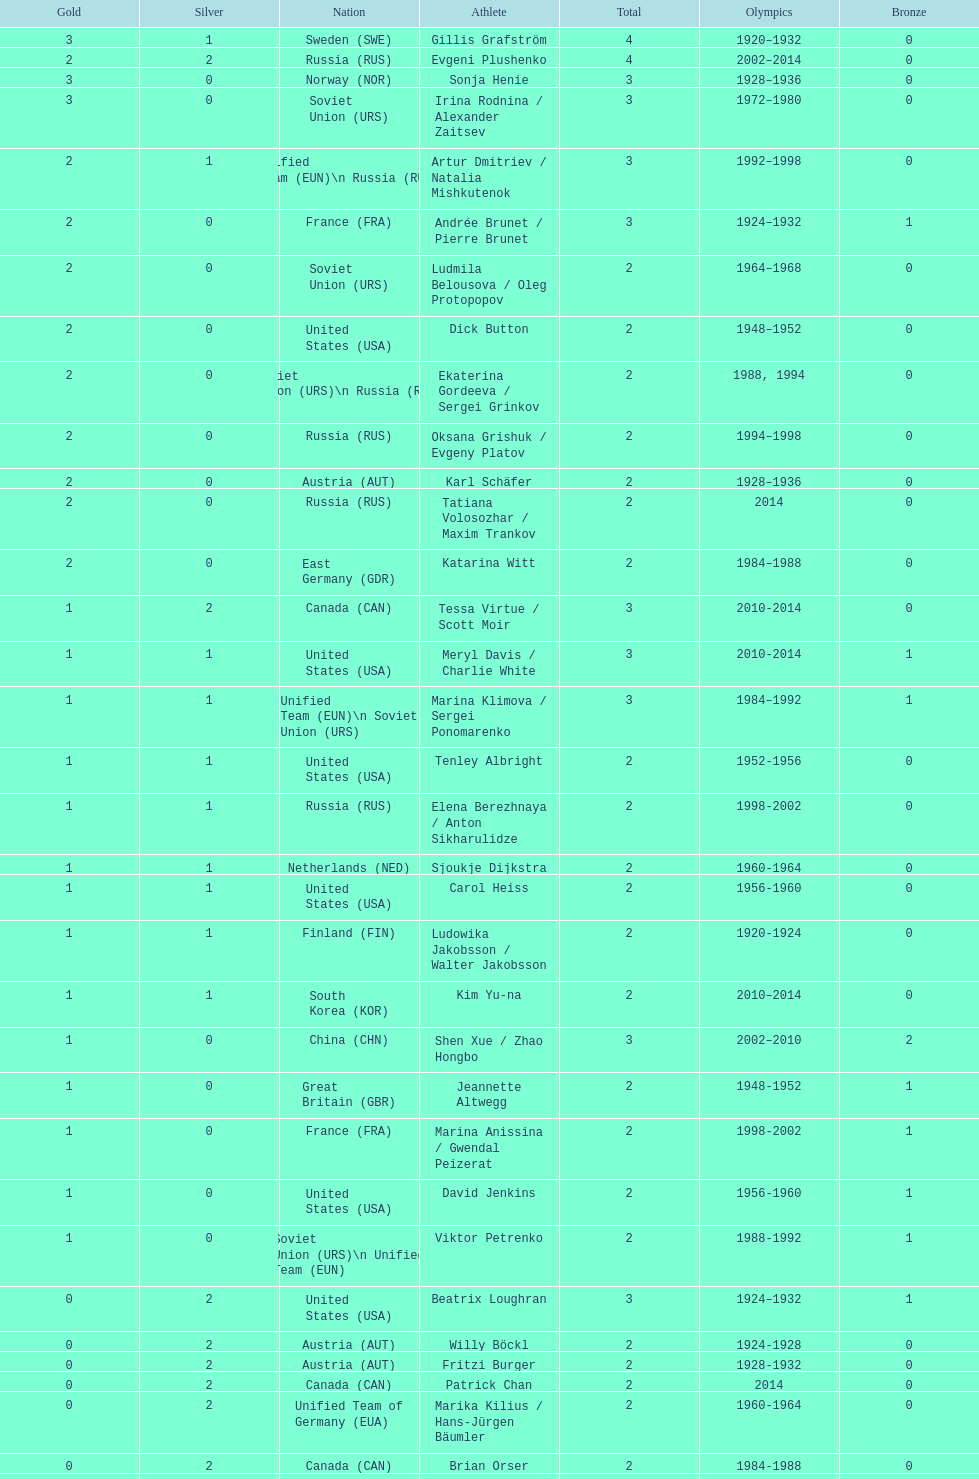What is the number of silver medals obtained by evgeni plushenko? 2. 